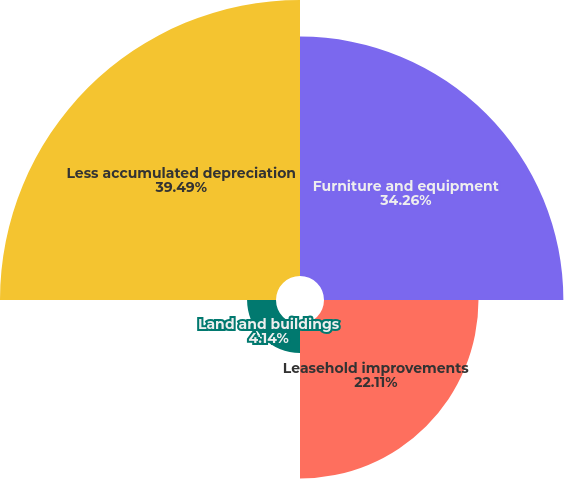Convert chart. <chart><loc_0><loc_0><loc_500><loc_500><pie_chart><fcel>Furniture and equipment<fcel>Leasehold improvements<fcel>Land and buildings<fcel>Less accumulated depreciation<nl><fcel>34.26%<fcel>22.11%<fcel>4.14%<fcel>39.5%<nl></chart> 